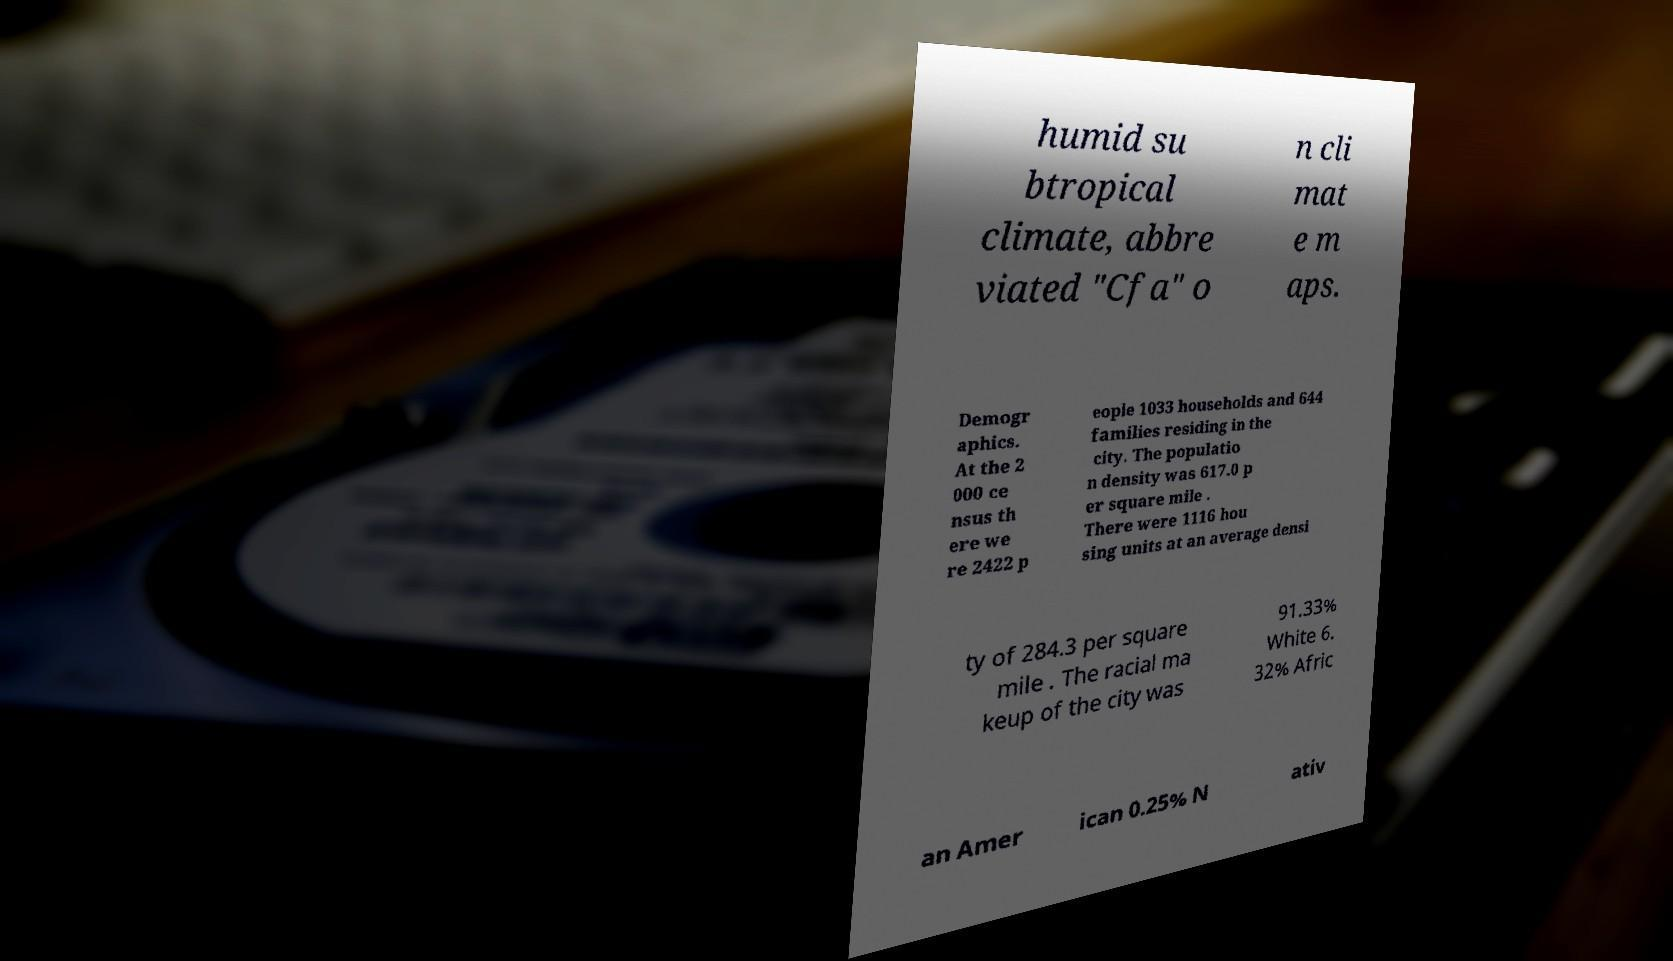For documentation purposes, I need the text within this image transcribed. Could you provide that? humid su btropical climate, abbre viated "Cfa" o n cli mat e m aps. Demogr aphics. At the 2 000 ce nsus th ere we re 2422 p eople 1033 households and 644 families residing in the city. The populatio n density was 617.0 p er square mile . There were 1116 hou sing units at an average densi ty of 284.3 per square mile . The racial ma keup of the city was 91.33% White 6. 32% Afric an Amer ican 0.25% N ativ 